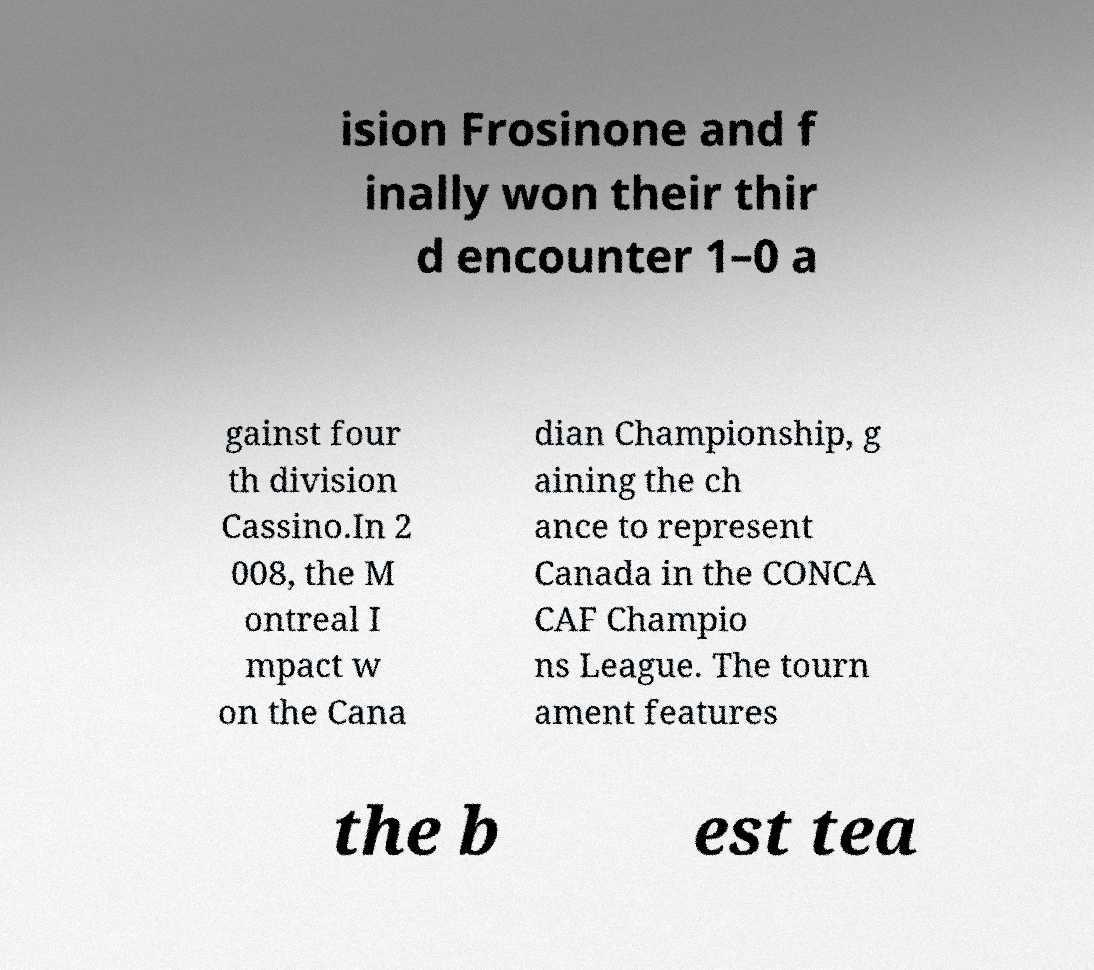Could you extract and type out the text from this image? ision Frosinone and f inally won their thir d encounter 1–0 a gainst four th division Cassino.In 2 008, the M ontreal I mpact w on the Cana dian Championship, g aining the ch ance to represent Canada in the CONCA CAF Champio ns League. The tourn ament features the b est tea 